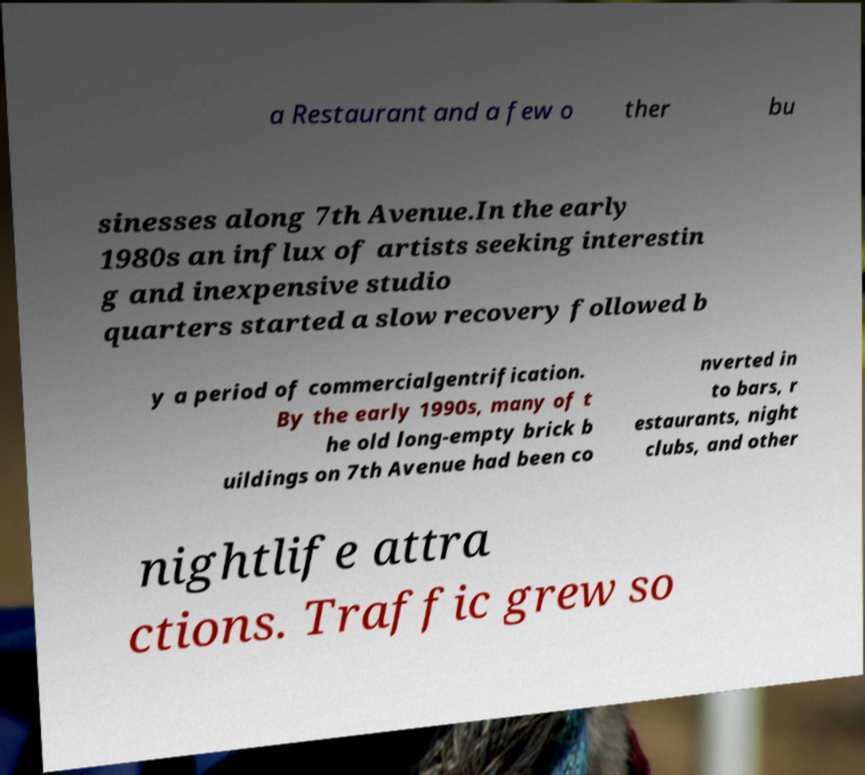For documentation purposes, I need the text within this image transcribed. Could you provide that? a Restaurant and a few o ther bu sinesses along 7th Avenue.In the early 1980s an influx of artists seeking interestin g and inexpensive studio quarters started a slow recovery followed b y a period of commercialgentrification. By the early 1990s, many of t he old long-empty brick b uildings on 7th Avenue had been co nverted in to bars, r estaurants, night clubs, and other nightlife attra ctions. Traffic grew so 